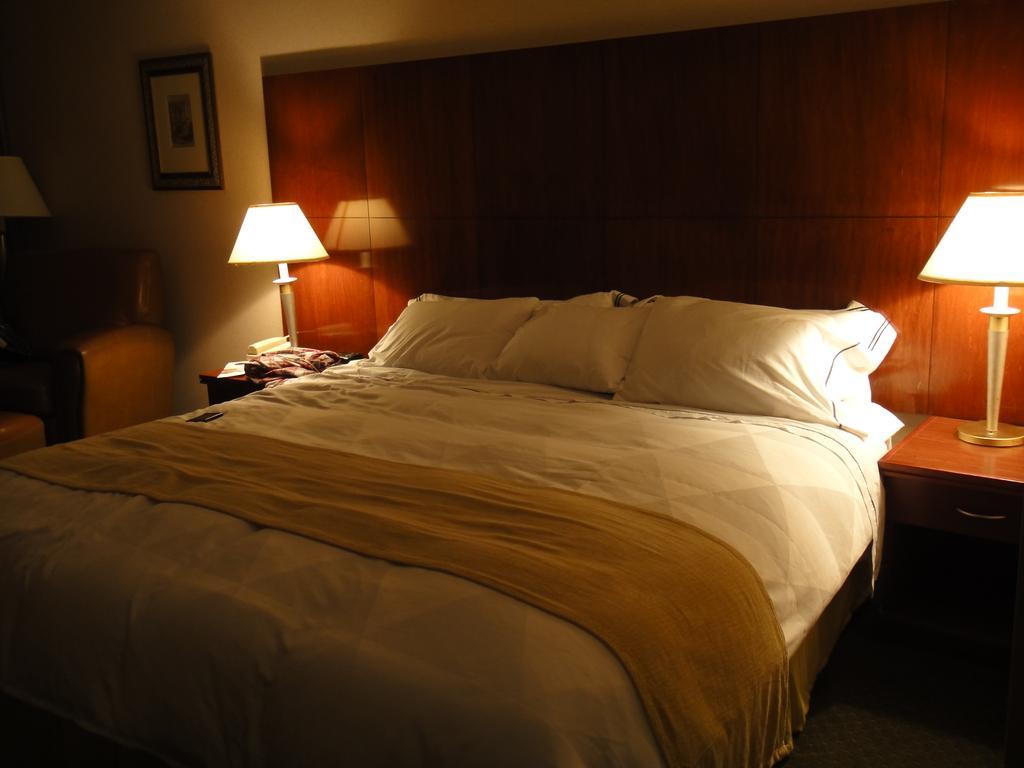Describe this image in one or two sentences. In this image I can see a bed. There are three pillows on the bed. There are two lamps on the table. I can see a photo frame on the wall. 